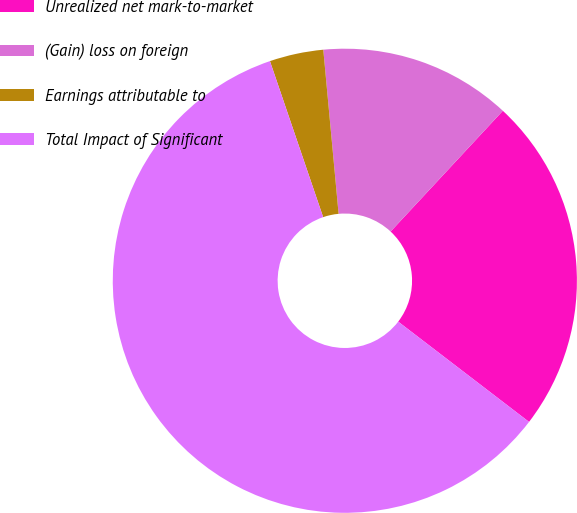Convert chart to OTSL. <chart><loc_0><loc_0><loc_500><loc_500><pie_chart><fcel>Unrealized net mark-to-market<fcel>(Gain) loss on foreign<fcel>Earnings attributable to<fcel>Total Impact of Significant<nl><fcel>23.49%<fcel>13.4%<fcel>3.75%<fcel>59.37%<nl></chart> 